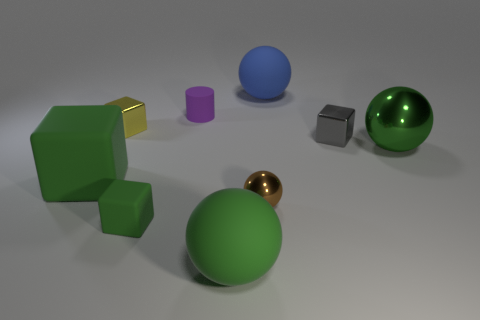Subtract 1 cubes. How many cubes are left? 3 Subtract all brown blocks. Subtract all brown balls. How many blocks are left? 4 Add 1 large green matte spheres. How many objects exist? 10 Subtract all cubes. How many objects are left? 5 Add 2 gray metallic cubes. How many gray metallic cubes are left? 3 Add 7 brown things. How many brown things exist? 8 Subtract 0 blue cylinders. How many objects are left? 9 Subtract all big purple metal objects. Subtract all tiny purple things. How many objects are left? 8 